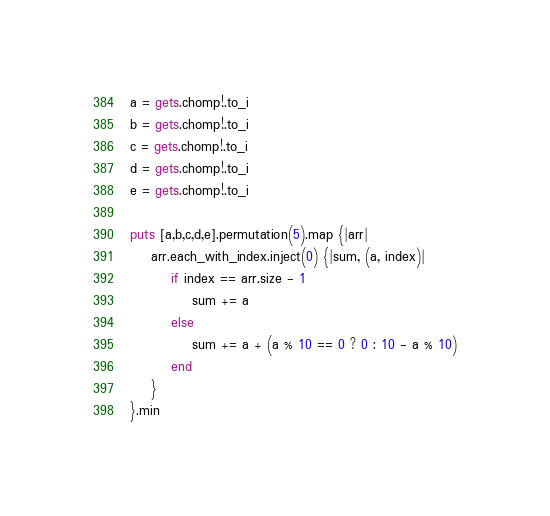<code> <loc_0><loc_0><loc_500><loc_500><_Ruby_>a = gets.chomp!.to_i
b = gets.chomp!.to_i
c = gets.chomp!.to_i
d = gets.chomp!.to_i
e = gets.chomp!.to_i

puts [a,b,c,d,e].permutation(5).map {|arr|
    arr.each_with_index.inject(0) {|sum, (a, index)|
        if index == arr.size - 1
            sum += a
        else
            sum += a + (a % 10 == 0 ? 0 : 10 - a % 10)
        end
    }
}.min</code> 